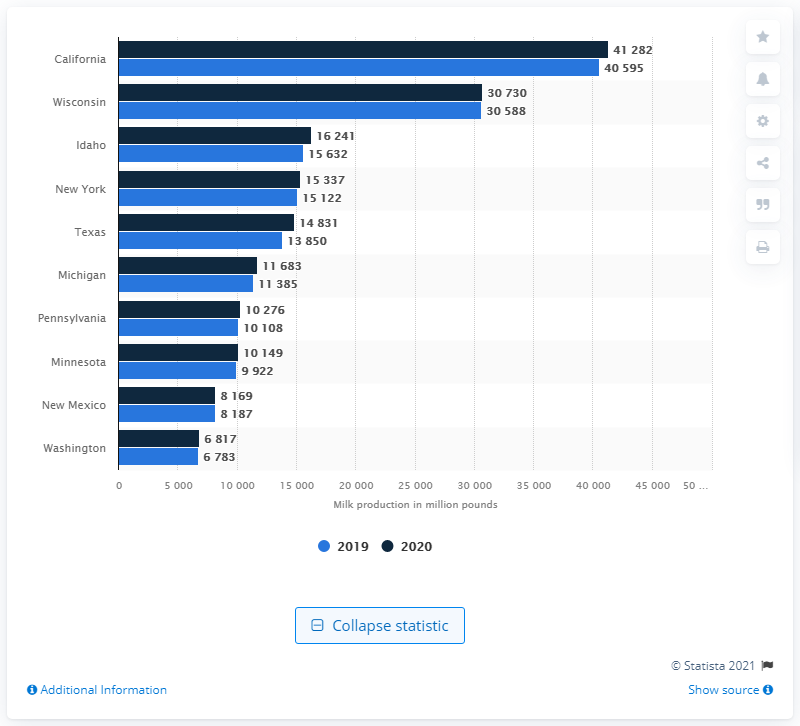Mention a couple of crucial points in this snapshot. California produced the most milk in 2020. 